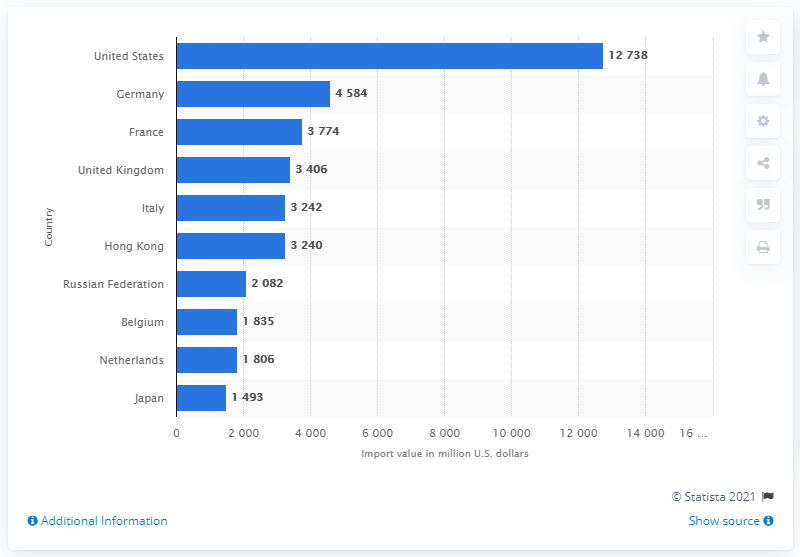Highlight a few significant elements in this photo. In 2013, the import value of leather footwear in the United States was 12,738. 